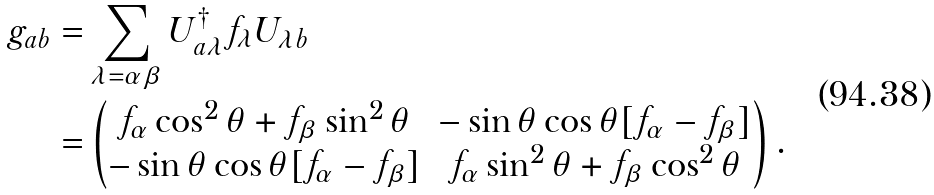Convert formula to latex. <formula><loc_0><loc_0><loc_500><loc_500>g _ { a b } = & \sum _ { \lambda = \alpha \beta } U _ { a \lambda } ^ { \dag } f _ { \lambda } U _ { \lambda b } \\ = & \begin{pmatrix} f _ { \alpha } \cos ^ { 2 } \theta + f _ { \beta } \sin ^ { 2 } \theta & - \sin \theta \cos \theta [ f _ { \alpha } - f _ { \beta } ] \\ - \sin \theta \cos \theta [ f _ { \alpha } - f _ { \beta } ] & f _ { \alpha } \sin ^ { 2 } \theta + f _ { \beta } \cos ^ { 2 } \theta \\ \end{pmatrix} .</formula> 